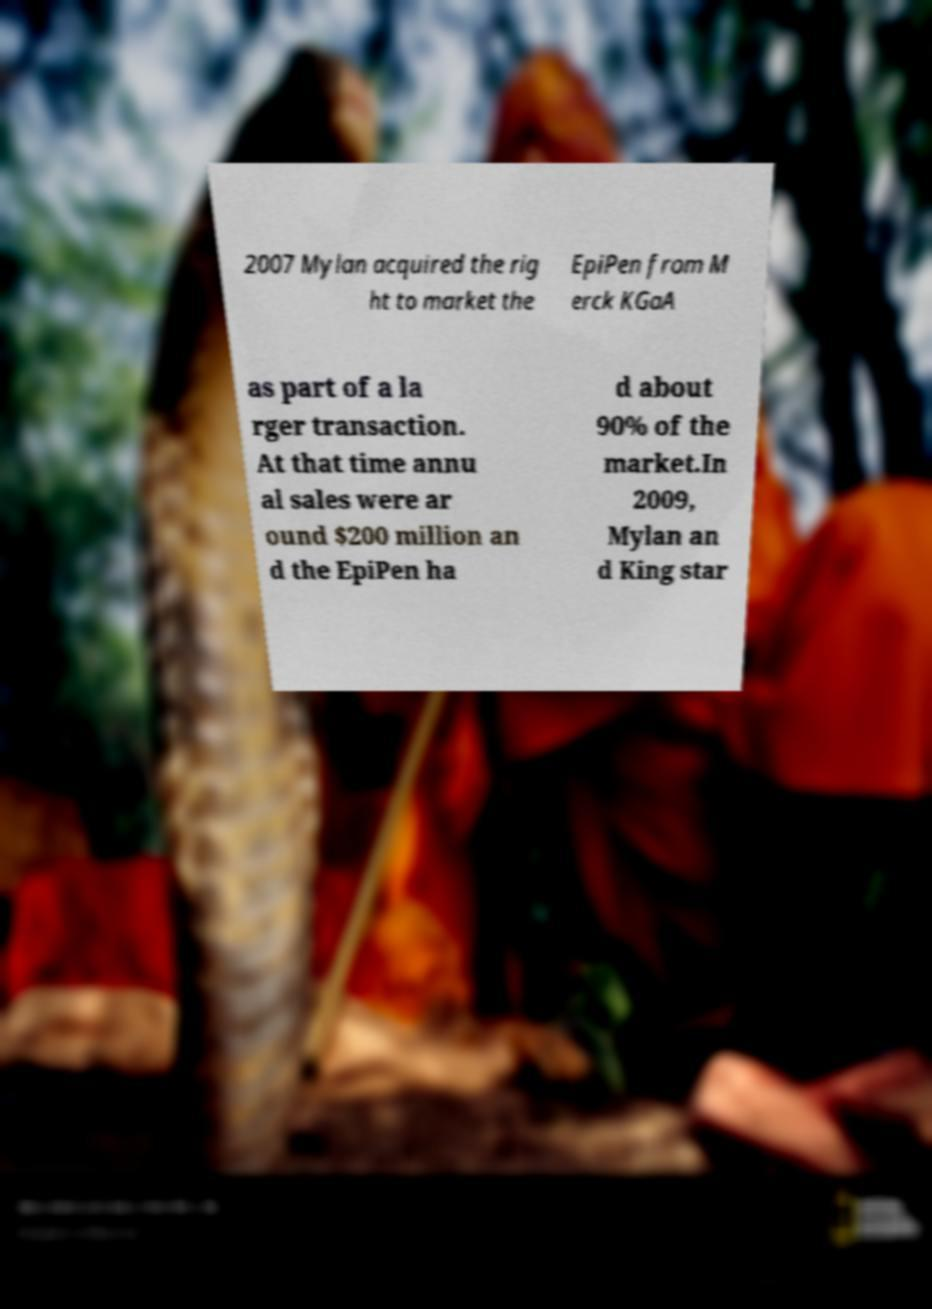Please read and relay the text visible in this image. What does it say? 2007 Mylan acquired the rig ht to market the EpiPen from M erck KGaA as part of a la rger transaction. At that time annu al sales were ar ound $200 million an d the EpiPen ha d about 90% of the market.In 2009, Mylan an d King star 